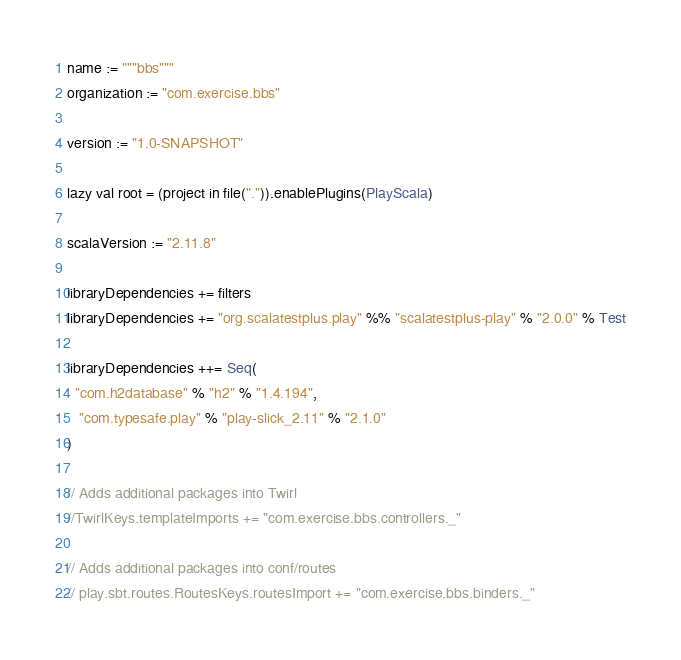Convert code to text. <code><loc_0><loc_0><loc_500><loc_500><_Scala_>name := """bbs"""
organization := "com.exercise.bbs"

version := "1.0-SNAPSHOT"

lazy val root = (project in file(".")).enablePlugins(PlayScala)

scalaVersion := "2.11.8"

libraryDependencies += filters
libraryDependencies += "org.scalatestplus.play" %% "scalatestplus-play" % "2.0.0" % Test

libraryDependencies ++= Seq(
  "com.h2database" % "h2" % "1.4.194",
   "com.typesafe.play" % "play-slick_2.11" % "2.1.0"
)

// Adds additional packages into Twirl
//TwirlKeys.templateImports += "com.exercise.bbs.controllers._"

// Adds additional packages into conf/routes
// play.sbt.routes.RoutesKeys.routesImport += "com.exercise.bbs.binders._"
</code> 